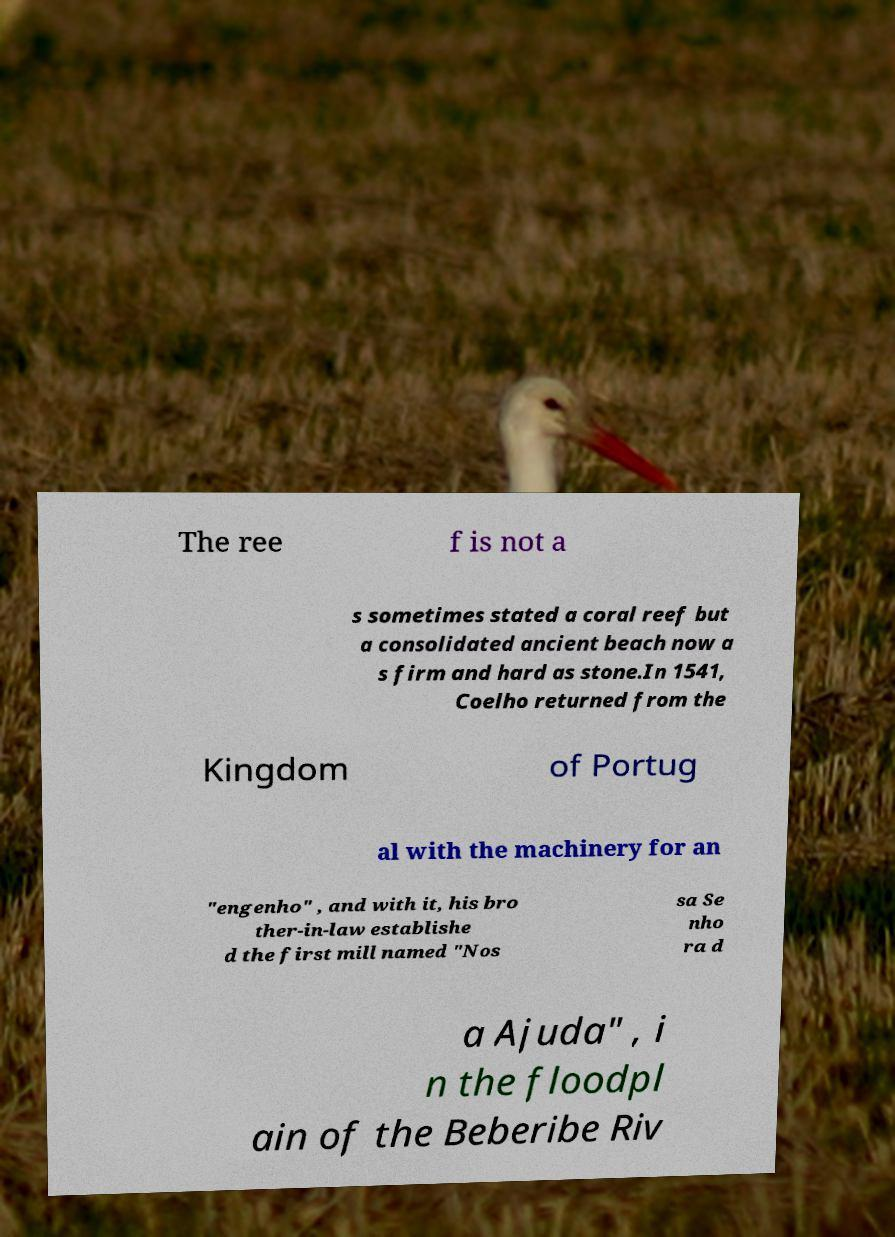Please read and relay the text visible in this image. What does it say? The ree f is not a s sometimes stated a coral reef but a consolidated ancient beach now a s firm and hard as stone.In 1541, Coelho returned from the Kingdom of Portug al with the machinery for an "engenho" , and with it, his bro ther-in-law establishe d the first mill named "Nos sa Se nho ra d a Ajuda" , i n the floodpl ain of the Beberibe Riv 